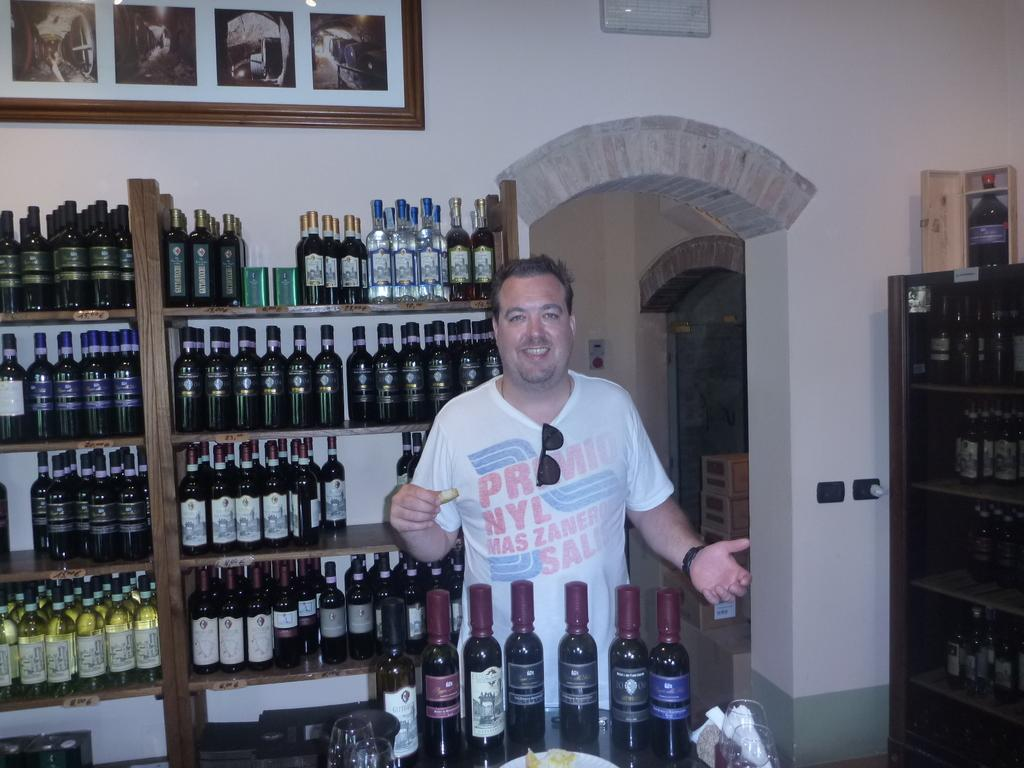<image>
Describe the image concisely. A man wearing a white that has NYL on it is standing in a room full of wines. 